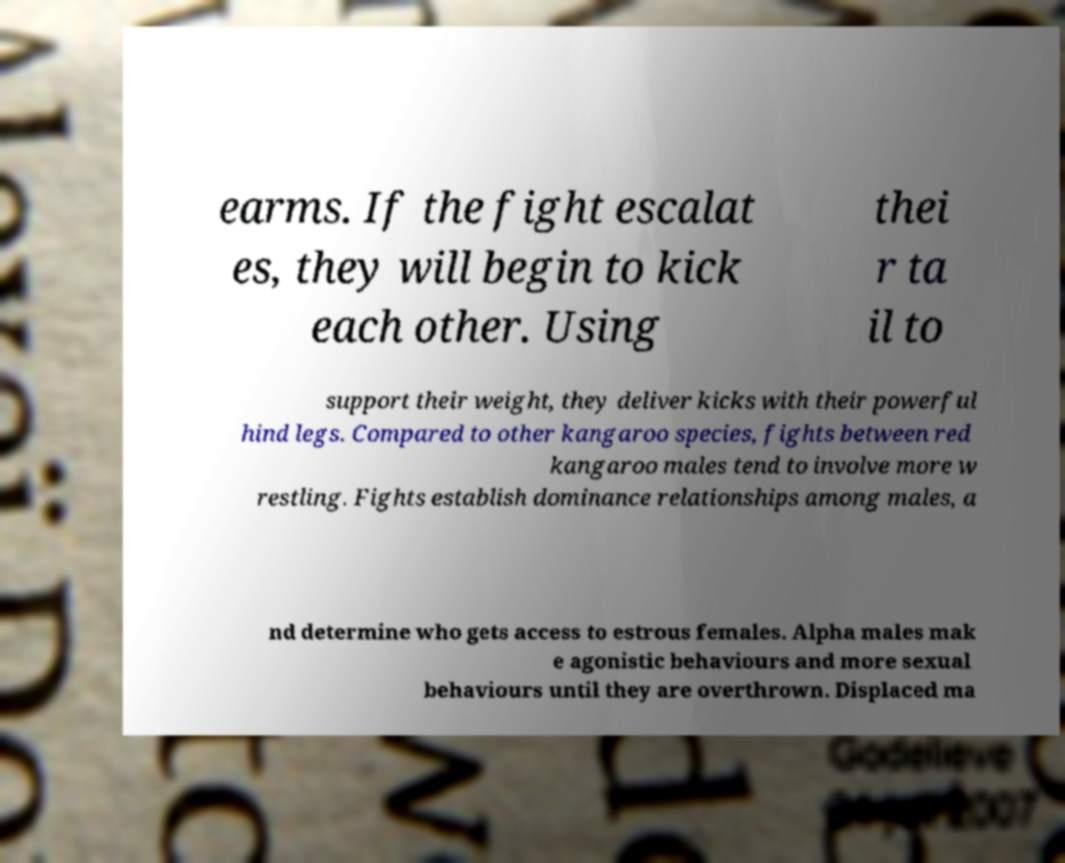Please read and relay the text visible in this image. What does it say? earms. If the fight escalat es, they will begin to kick each other. Using thei r ta il to support their weight, they deliver kicks with their powerful hind legs. Compared to other kangaroo species, fights between red kangaroo males tend to involve more w restling. Fights establish dominance relationships among males, a nd determine who gets access to estrous females. Alpha males mak e agonistic behaviours and more sexual behaviours until they are overthrown. Displaced ma 